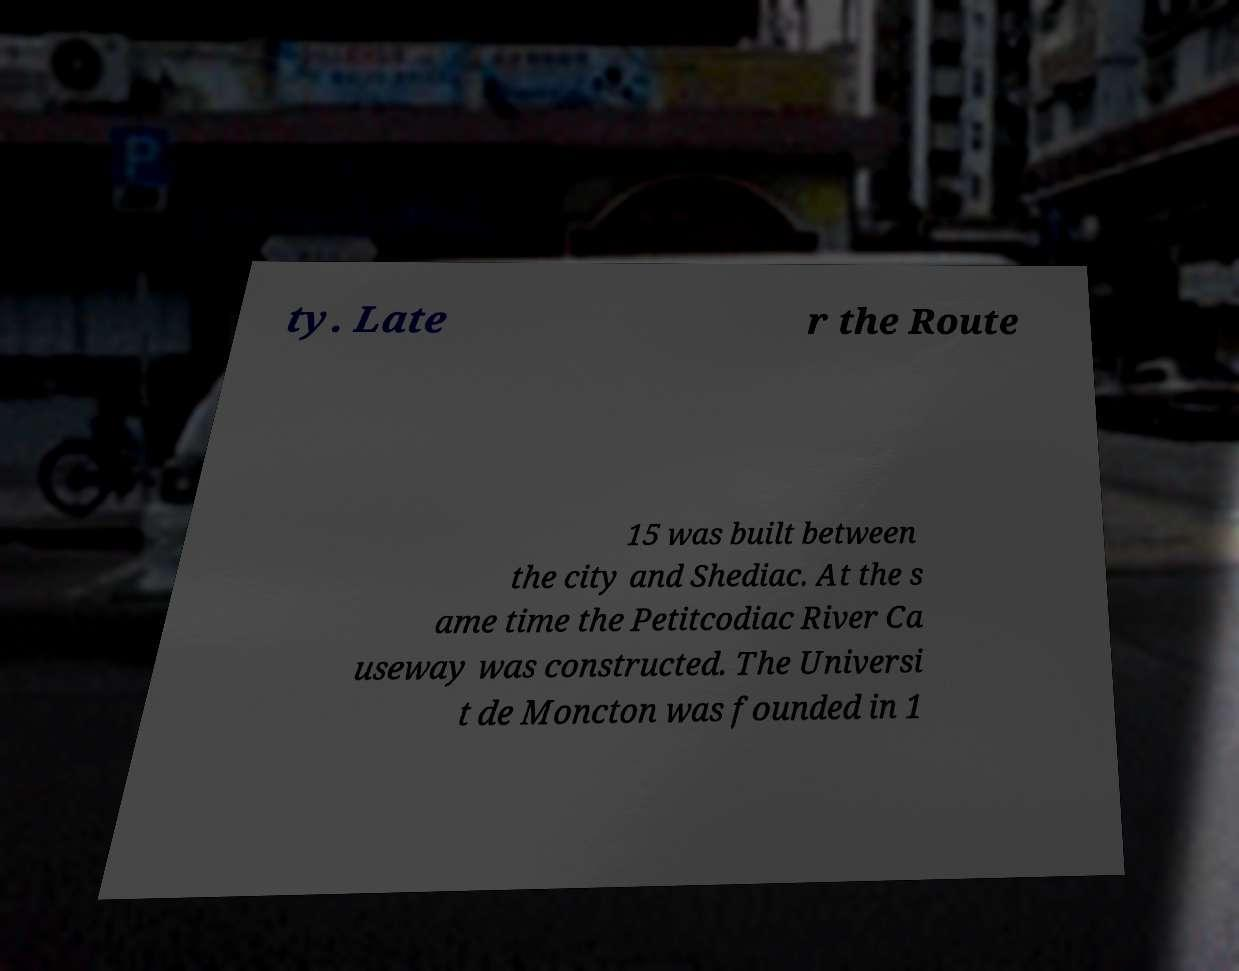What messages or text are displayed in this image? I need them in a readable, typed format. ty. Late r the Route 15 was built between the city and Shediac. At the s ame time the Petitcodiac River Ca useway was constructed. The Universi t de Moncton was founded in 1 